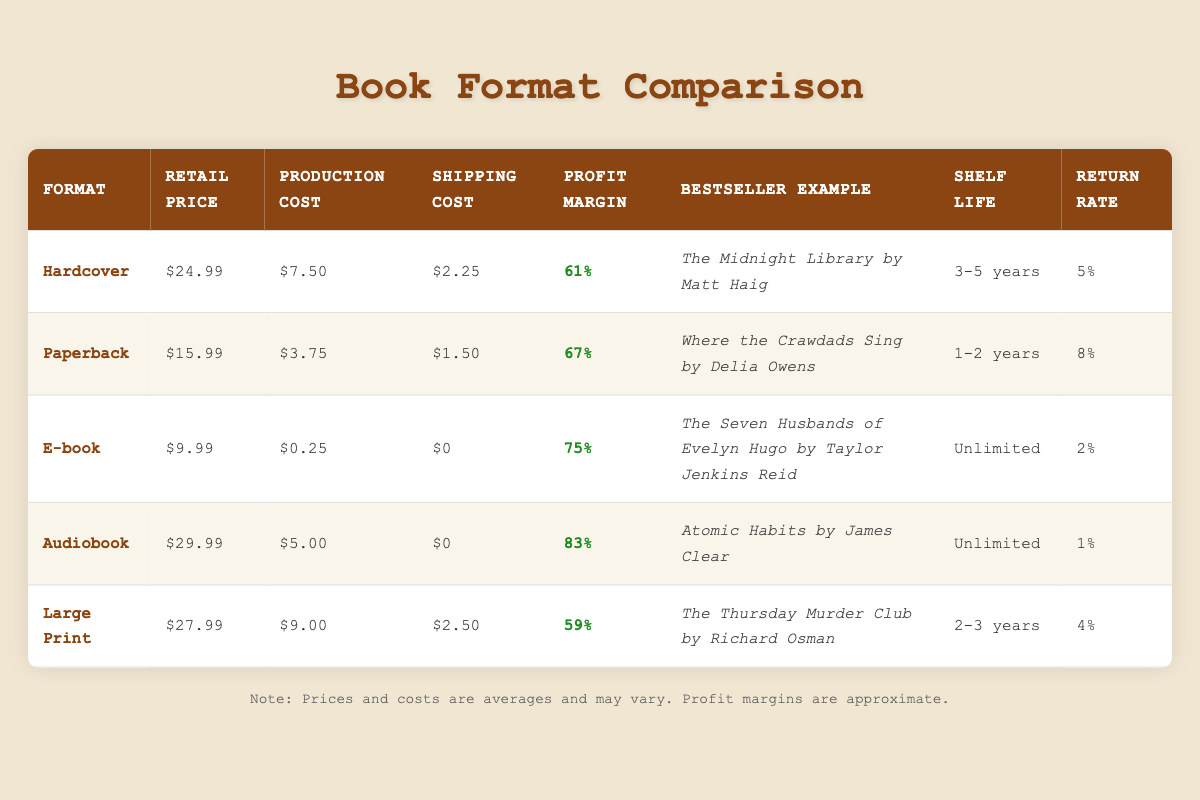What is the profit margin percentage for the Audiobook format? The profit margin percentage for the Audiobook format is listed directly in the table under the respective column, which shows 83%.
Answer: 83% Which book format has the highest average retail price? By reviewing the average retail prices for all the formats listed, the Audiobook format has the highest price at $29.99, compared to others, confirming it as the highest.
Answer: Audiobook How much higher is the profit margin for E-books compared to Large Print? The profit margin for E-books is 75% and for Large Print is 59%. To find the difference, we subtract 59 from 75, which equals 16%.
Answer: 16% Is the return rate for E-books less than that for Hardcover books? The return rate for E-books is 2% and for Hardcover is 5%. Since 2% is less than 5%, the statement is true.
Answer: Yes What is the total profit margin percentage for Hardcover and Paperback formats combined? The profit margin percentages for Hardcover and Paperback are 61% and 67%, respectively. Adding them gives us a total of 128%.
Answer: 128% Which format has the longest shelf life? Observing the shelf life for each format, the E-book has an unlimited shelf life, which is the longest compared to other formats listed in the table.
Answer: E-book What is the average retail price of the Paperback and Large Print formats? The average retail price of the Paperback is $15.99 and that of Large Print is $27.99. To find the average, we sum them up (15.99 + 27.99) and divide by 2, resulting in $21.99.
Answer: $21.99 Does the Audiobook have a higher return rate than the Paperback? The return rate for Audiobook is 1% while for Paperback it is 8%. Since 1% is not higher than 8%, the statement is false.
Answer: No Which bestselling example corresponds to the Hardcover format? The bestselling example for Hardcover, as mentioned in the table, is "The Midnight Library by Matt Haig."
Answer: The Midnight Library by Matt Haig 